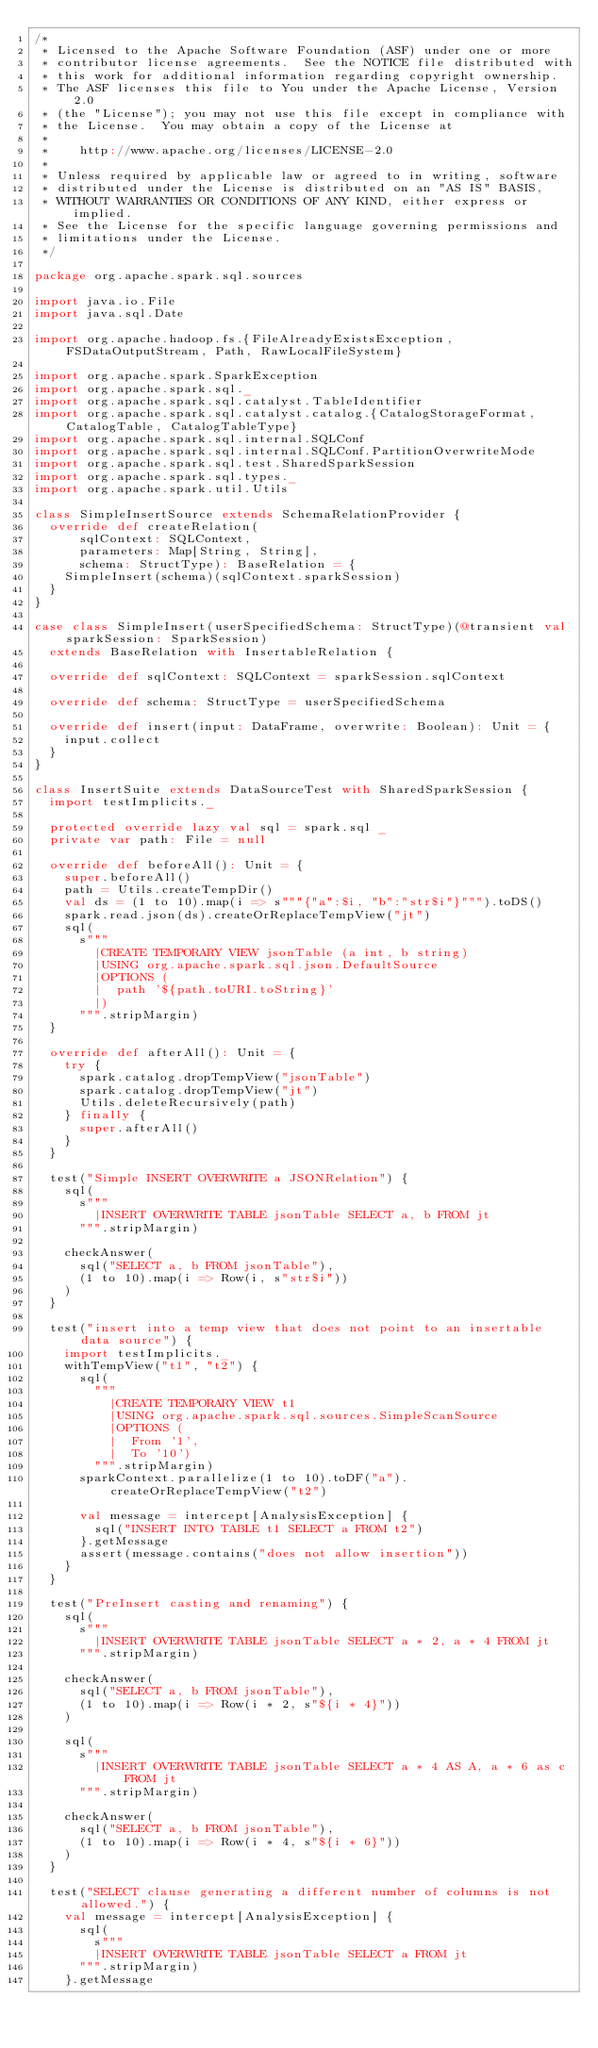Convert code to text. <code><loc_0><loc_0><loc_500><loc_500><_Scala_>/*
 * Licensed to the Apache Software Foundation (ASF) under one or more
 * contributor license agreements.  See the NOTICE file distributed with
 * this work for additional information regarding copyright ownership.
 * The ASF licenses this file to You under the Apache License, Version 2.0
 * (the "License"); you may not use this file except in compliance with
 * the License.  You may obtain a copy of the License at
 *
 *    http://www.apache.org/licenses/LICENSE-2.0
 *
 * Unless required by applicable law or agreed to in writing, software
 * distributed under the License is distributed on an "AS IS" BASIS,
 * WITHOUT WARRANTIES OR CONDITIONS OF ANY KIND, either express or implied.
 * See the License for the specific language governing permissions and
 * limitations under the License.
 */

package org.apache.spark.sql.sources

import java.io.File
import java.sql.Date

import org.apache.hadoop.fs.{FileAlreadyExistsException, FSDataOutputStream, Path, RawLocalFileSystem}

import org.apache.spark.SparkException
import org.apache.spark.sql._
import org.apache.spark.sql.catalyst.TableIdentifier
import org.apache.spark.sql.catalyst.catalog.{CatalogStorageFormat, CatalogTable, CatalogTableType}
import org.apache.spark.sql.internal.SQLConf
import org.apache.spark.sql.internal.SQLConf.PartitionOverwriteMode
import org.apache.spark.sql.test.SharedSparkSession
import org.apache.spark.sql.types._
import org.apache.spark.util.Utils

class SimpleInsertSource extends SchemaRelationProvider {
  override def createRelation(
      sqlContext: SQLContext,
      parameters: Map[String, String],
      schema: StructType): BaseRelation = {
    SimpleInsert(schema)(sqlContext.sparkSession)
  }
}

case class SimpleInsert(userSpecifiedSchema: StructType)(@transient val sparkSession: SparkSession)
  extends BaseRelation with InsertableRelation {

  override def sqlContext: SQLContext = sparkSession.sqlContext

  override def schema: StructType = userSpecifiedSchema

  override def insert(input: DataFrame, overwrite: Boolean): Unit = {
    input.collect
  }
}

class InsertSuite extends DataSourceTest with SharedSparkSession {
  import testImplicits._

  protected override lazy val sql = spark.sql _
  private var path: File = null

  override def beforeAll(): Unit = {
    super.beforeAll()
    path = Utils.createTempDir()
    val ds = (1 to 10).map(i => s"""{"a":$i, "b":"str$i"}""").toDS()
    spark.read.json(ds).createOrReplaceTempView("jt")
    sql(
      s"""
        |CREATE TEMPORARY VIEW jsonTable (a int, b string)
        |USING org.apache.spark.sql.json.DefaultSource
        |OPTIONS (
        |  path '${path.toURI.toString}'
        |)
      """.stripMargin)
  }

  override def afterAll(): Unit = {
    try {
      spark.catalog.dropTempView("jsonTable")
      spark.catalog.dropTempView("jt")
      Utils.deleteRecursively(path)
    } finally {
      super.afterAll()
    }
  }

  test("Simple INSERT OVERWRITE a JSONRelation") {
    sql(
      s"""
        |INSERT OVERWRITE TABLE jsonTable SELECT a, b FROM jt
      """.stripMargin)

    checkAnswer(
      sql("SELECT a, b FROM jsonTable"),
      (1 to 10).map(i => Row(i, s"str$i"))
    )
  }

  test("insert into a temp view that does not point to an insertable data source") {
    import testImplicits._
    withTempView("t1", "t2") {
      sql(
        """
          |CREATE TEMPORARY VIEW t1
          |USING org.apache.spark.sql.sources.SimpleScanSource
          |OPTIONS (
          |  From '1',
          |  To '10')
        """.stripMargin)
      sparkContext.parallelize(1 to 10).toDF("a").createOrReplaceTempView("t2")

      val message = intercept[AnalysisException] {
        sql("INSERT INTO TABLE t1 SELECT a FROM t2")
      }.getMessage
      assert(message.contains("does not allow insertion"))
    }
  }

  test("PreInsert casting and renaming") {
    sql(
      s"""
        |INSERT OVERWRITE TABLE jsonTable SELECT a * 2, a * 4 FROM jt
      """.stripMargin)

    checkAnswer(
      sql("SELECT a, b FROM jsonTable"),
      (1 to 10).map(i => Row(i * 2, s"${i * 4}"))
    )

    sql(
      s"""
        |INSERT OVERWRITE TABLE jsonTable SELECT a * 4 AS A, a * 6 as c FROM jt
      """.stripMargin)

    checkAnswer(
      sql("SELECT a, b FROM jsonTable"),
      (1 to 10).map(i => Row(i * 4, s"${i * 6}"))
    )
  }

  test("SELECT clause generating a different number of columns is not allowed.") {
    val message = intercept[AnalysisException] {
      sql(
        s"""
        |INSERT OVERWRITE TABLE jsonTable SELECT a FROM jt
      """.stripMargin)
    }.getMessage</code> 